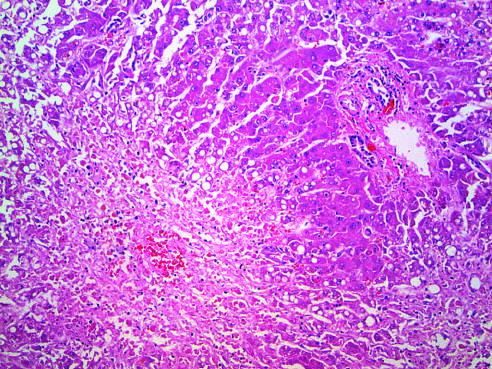s the shape and volume of the left ventricle caused by acetaminophen overdose?
Answer the question using a single word or phrase. No 